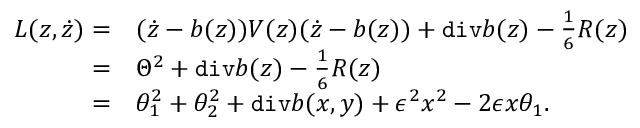<formula> <loc_0><loc_0><loc_500><loc_500>\begin{array} { r l } { L ( z , \dot { z } ) = } & { ( \dot { z } - b ( z ) ) V ( z ) ( \dot { z } - b ( z ) ) + d i v b ( z ) - \frac { 1 } { 6 } R ( z ) } \\ { = } & { \Theta ^ { 2 } + d i v b ( z ) - \frac { 1 } { 6 } R ( z ) } \\ { = } & { \theta _ { 1 } ^ { 2 } + \theta _ { 2 } ^ { 2 } + d i v b ( x , y ) + \epsilon ^ { 2 } x ^ { 2 } - 2 \epsilon x \theta _ { 1 } . } \end{array}</formula> 